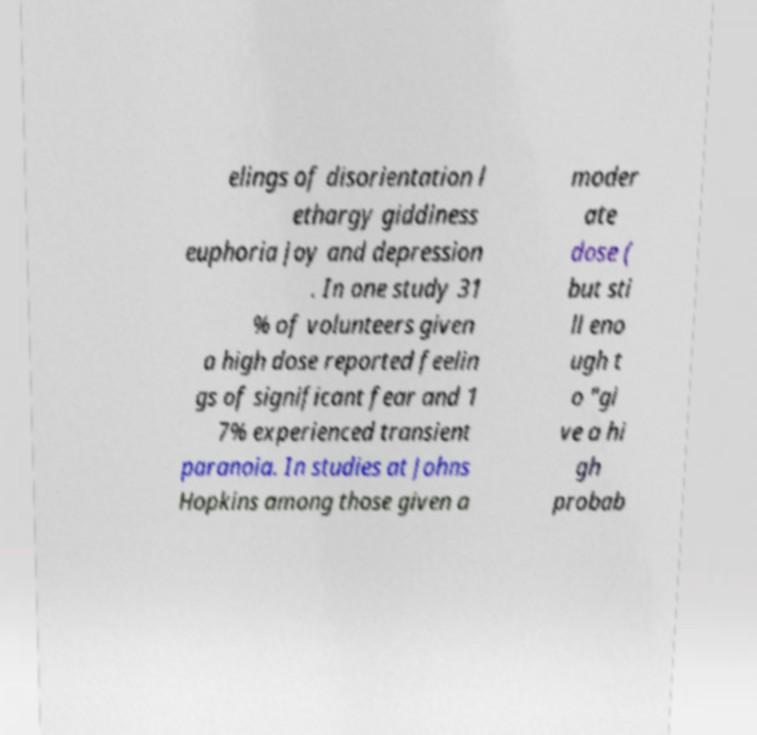Could you assist in decoding the text presented in this image and type it out clearly? elings of disorientation l ethargy giddiness euphoria joy and depression . In one study 31 % of volunteers given a high dose reported feelin gs of significant fear and 1 7% experienced transient paranoia. In studies at Johns Hopkins among those given a moder ate dose ( but sti ll eno ugh t o "gi ve a hi gh probab 